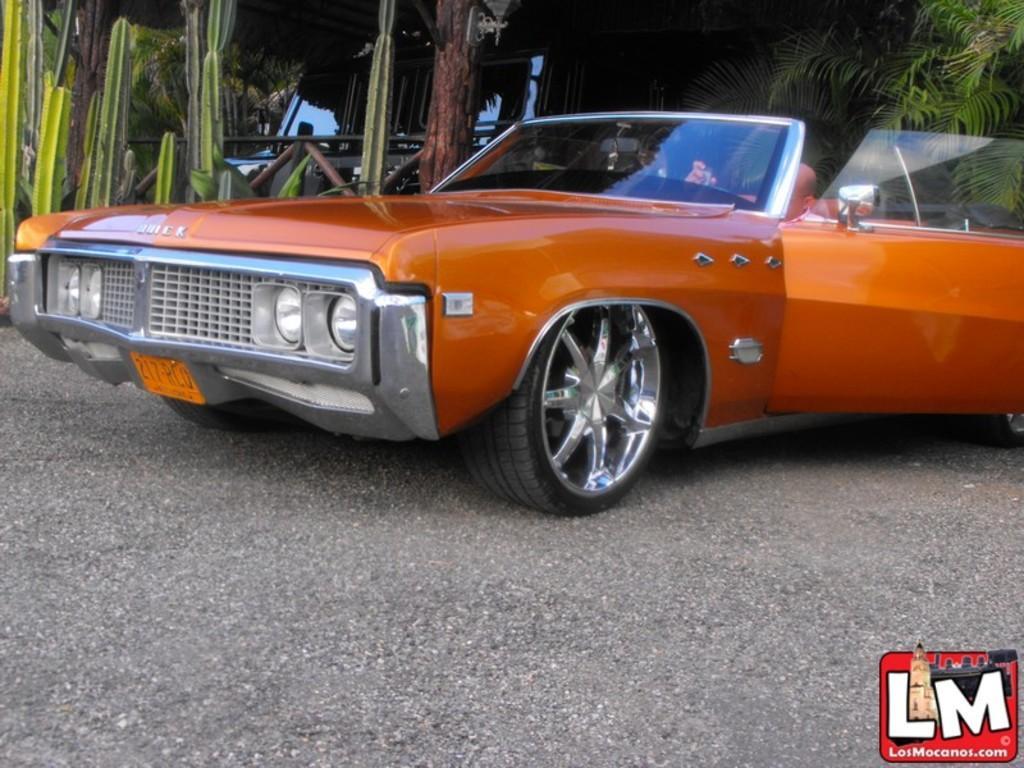Please provide a concise description of this image. In this image we can see some vehicles parked on the ground. On the left side of the image we can see some plants. In the background, we can see a lamp and some trees. 